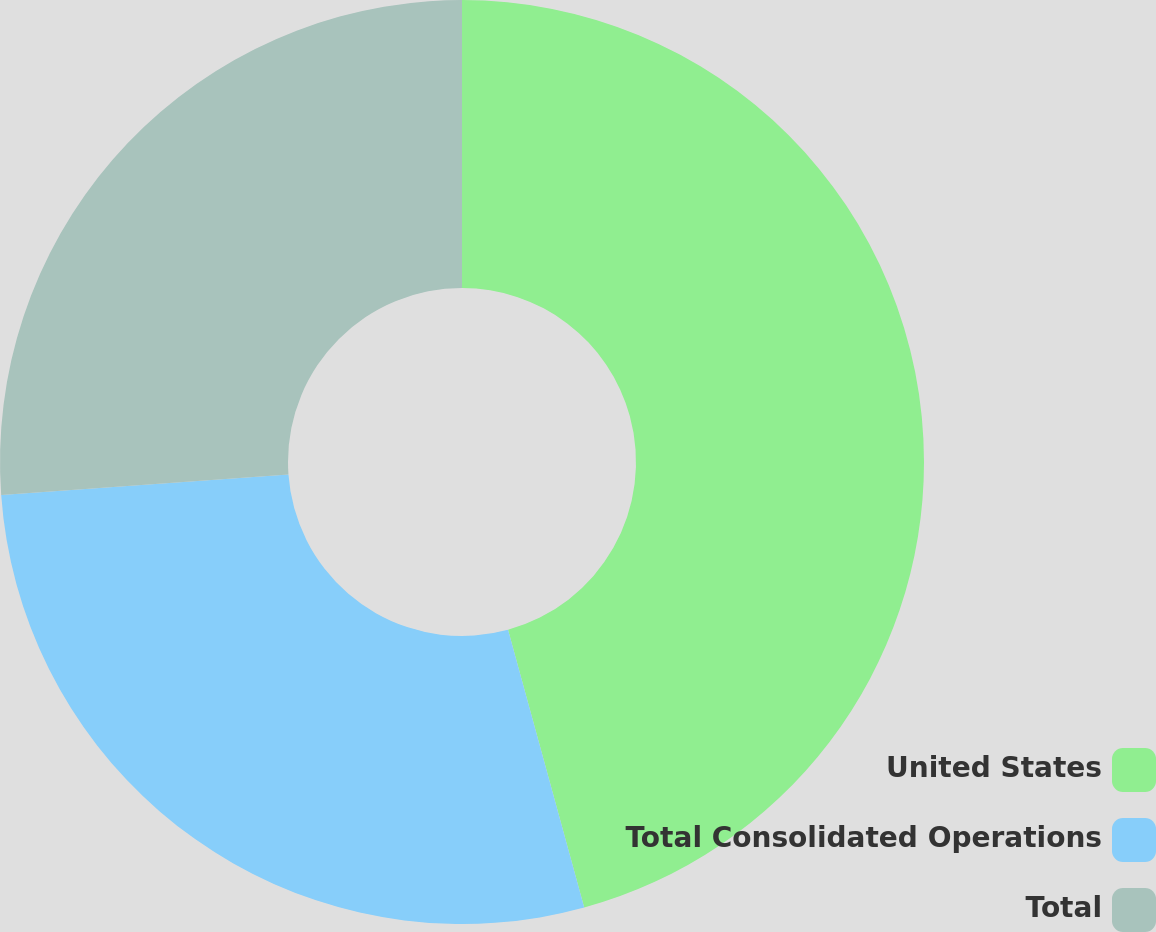<chart> <loc_0><loc_0><loc_500><loc_500><pie_chart><fcel>United States<fcel>Total Consolidated Operations<fcel>Total<nl><fcel>45.74%<fcel>28.12%<fcel>26.14%<nl></chart> 